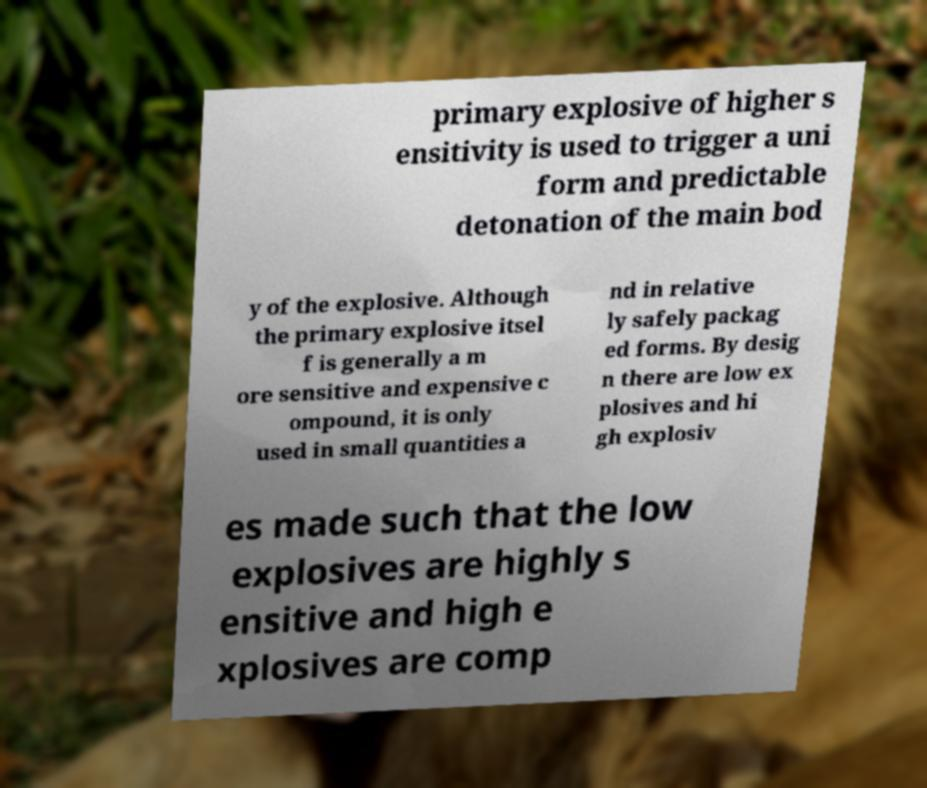Please read and relay the text visible in this image. What does it say? primary explosive of higher s ensitivity is used to trigger a uni form and predictable detonation of the main bod y of the explosive. Although the primary explosive itsel f is generally a m ore sensitive and expensive c ompound, it is only used in small quantities a nd in relative ly safely packag ed forms. By desig n there are low ex plosives and hi gh explosiv es made such that the low explosives are highly s ensitive and high e xplosives are comp 